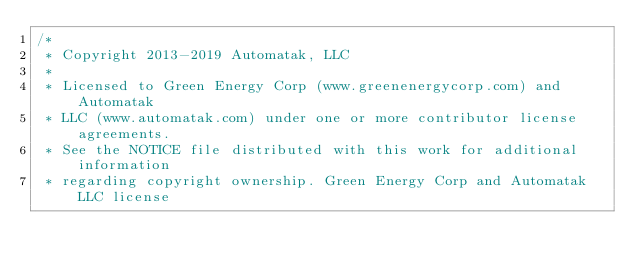Convert code to text. <code><loc_0><loc_0><loc_500><loc_500><_C++_>/*
 * Copyright 2013-2019 Automatak, LLC
 *
 * Licensed to Green Energy Corp (www.greenenergycorp.com) and Automatak
 * LLC (www.automatak.com) under one or more contributor license agreements.
 * See the NOTICE file distributed with this work for additional information
 * regarding copyright ownership. Green Energy Corp and Automatak LLC license</code> 